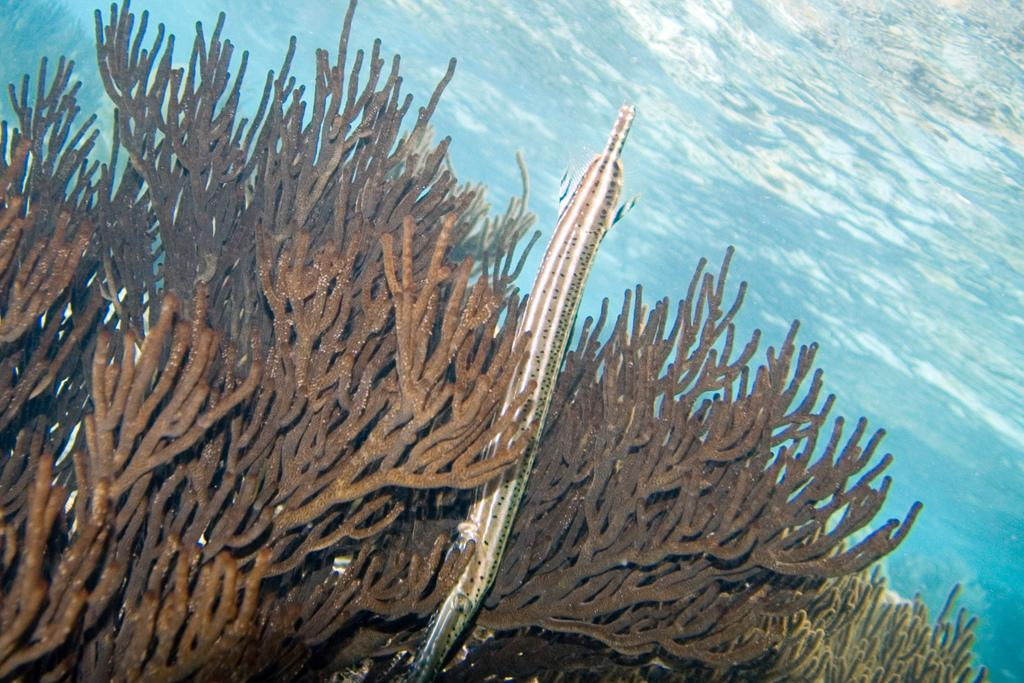What type of environment is shown in the image? The image depicts an underwater environment. Can you describe any living creatures in the image? There is an animal visible in the image. What type of cheese can be seen hanging from the ceiling in the image? There is no cheese present in the image, as it depicts an underwater environment. 